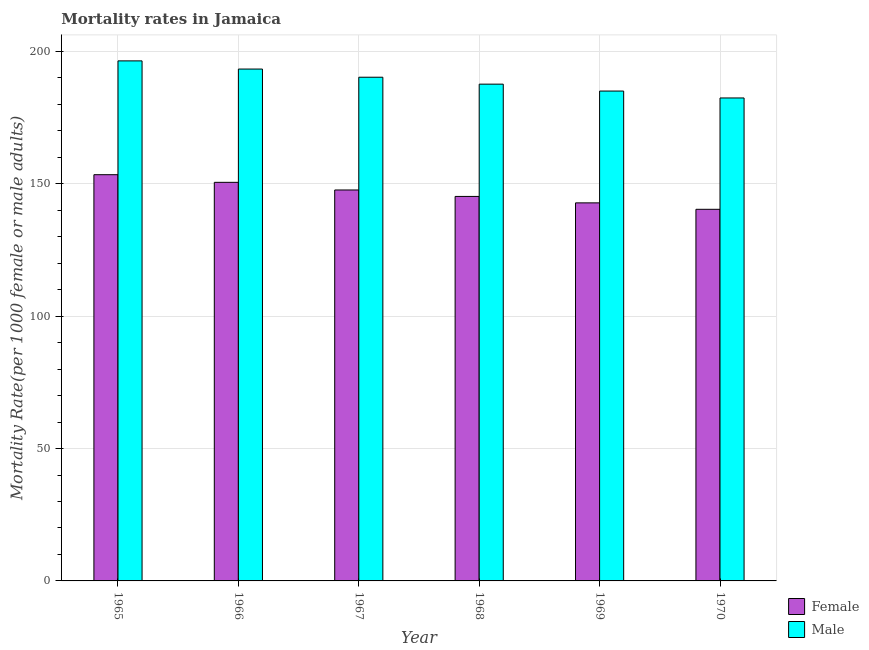How many different coloured bars are there?
Give a very brief answer. 2. Are the number of bars on each tick of the X-axis equal?
Ensure brevity in your answer.  Yes. How many bars are there on the 5th tick from the left?
Provide a succinct answer. 2. How many bars are there on the 2nd tick from the right?
Your response must be concise. 2. What is the label of the 1st group of bars from the left?
Offer a terse response. 1965. In how many cases, is the number of bars for a given year not equal to the number of legend labels?
Keep it short and to the point. 0. What is the male mortality rate in 1968?
Give a very brief answer. 187.66. Across all years, what is the maximum female mortality rate?
Offer a very short reply. 153.45. Across all years, what is the minimum male mortality rate?
Keep it short and to the point. 182.43. In which year was the female mortality rate maximum?
Give a very brief answer. 1965. What is the total female mortality rate in the graph?
Your answer should be compact. 880.11. What is the difference between the female mortality rate in 1966 and that in 1970?
Make the answer very short. 10.19. What is the difference between the female mortality rate in 1969 and the male mortality rate in 1965?
Give a very brief answer. -10.64. What is the average male mortality rate per year?
Offer a very short reply. 189.2. In the year 1970, what is the difference between the female mortality rate and male mortality rate?
Give a very brief answer. 0. In how many years, is the male mortality rate greater than 170?
Make the answer very short. 6. What is the ratio of the female mortality rate in 1966 to that in 1968?
Keep it short and to the point. 1.04. Is the difference between the female mortality rate in 1966 and 1968 greater than the difference between the male mortality rate in 1966 and 1968?
Offer a very short reply. No. What is the difference between the highest and the second highest female mortality rate?
Your answer should be compact. 2.89. What is the difference between the highest and the lowest female mortality rate?
Your answer should be compact. 13.08. Is the sum of the male mortality rate in 1966 and 1970 greater than the maximum female mortality rate across all years?
Offer a very short reply. Yes. What does the 1st bar from the left in 1968 represents?
Your response must be concise. Female. What does the 2nd bar from the right in 1969 represents?
Keep it short and to the point. Female. How many bars are there?
Your answer should be very brief. 12. Are all the bars in the graph horizontal?
Offer a terse response. No. How many years are there in the graph?
Give a very brief answer. 6. Are the values on the major ticks of Y-axis written in scientific E-notation?
Your response must be concise. No. Does the graph contain any zero values?
Your answer should be compact. No. How many legend labels are there?
Make the answer very short. 2. How are the legend labels stacked?
Make the answer very short. Vertical. What is the title of the graph?
Your response must be concise. Mortality rates in Jamaica. What is the label or title of the X-axis?
Your response must be concise. Year. What is the label or title of the Y-axis?
Provide a short and direct response. Mortality Rate(per 1000 female or male adults). What is the Mortality Rate(per 1000 female or male adults) of Female in 1965?
Provide a succinct answer. 153.45. What is the Mortality Rate(per 1000 female or male adults) in Male in 1965?
Provide a succinct answer. 196.44. What is the Mortality Rate(per 1000 female or male adults) in Female in 1966?
Offer a terse response. 150.56. What is the Mortality Rate(per 1000 female or male adults) in Male in 1966?
Ensure brevity in your answer.  193.36. What is the Mortality Rate(per 1000 female or male adults) of Female in 1967?
Make the answer very short. 147.68. What is the Mortality Rate(per 1000 female or male adults) of Male in 1967?
Offer a very short reply. 190.27. What is the Mortality Rate(per 1000 female or male adults) of Female in 1968?
Keep it short and to the point. 145.24. What is the Mortality Rate(per 1000 female or male adults) in Male in 1968?
Ensure brevity in your answer.  187.66. What is the Mortality Rate(per 1000 female or male adults) of Female in 1969?
Offer a terse response. 142.81. What is the Mortality Rate(per 1000 female or male adults) of Male in 1969?
Give a very brief answer. 185.04. What is the Mortality Rate(per 1000 female or male adults) in Female in 1970?
Offer a very short reply. 140.37. What is the Mortality Rate(per 1000 female or male adults) of Male in 1970?
Your response must be concise. 182.43. Across all years, what is the maximum Mortality Rate(per 1000 female or male adults) of Female?
Provide a short and direct response. 153.45. Across all years, what is the maximum Mortality Rate(per 1000 female or male adults) in Male?
Give a very brief answer. 196.44. Across all years, what is the minimum Mortality Rate(per 1000 female or male adults) in Female?
Give a very brief answer. 140.37. Across all years, what is the minimum Mortality Rate(per 1000 female or male adults) of Male?
Offer a terse response. 182.43. What is the total Mortality Rate(per 1000 female or male adults) of Female in the graph?
Give a very brief answer. 880.11. What is the total Mortality Rate(per 1000 female or male adults) of Male in the graph?
Offer a terse response. 1135.2. What is the difference between the Mortality Rate(per 1000 female or male adults) of Female in 1965 and that in 1966?
Your response must be concise. 2.89. What is the difference between the Mortality Rate(per 1000 female or male adults) of Male in 1965 and that in 1966?
Ensure brevity in your answer.  3.09. What is the difference between the Mortality Rate(per 1000 female or male adults) in Female in 1965 and that in 1967?
Ensure brevity in your answer.  5.78. What is the difference between the Mortality Rate(per 1000 female or male adults) in Male in 1965 and that in 1967?
Offer a very short reply. 6.18. What is the difference between the Mortality Rate(per 1000 female or male adults) in Female in 1965 and that in 1968?
Offer a terse response. 8.21. What is the difference between the Mortality Rate(per 1000 female or male adults) in Male in 1965 and that in 1968?
Your response must be concise. 8.79. What is the difference between the Mortality Rate(per 1000 female or male adults) of Female in 1965 and that in 1969?
Provide a short and direct response. 10.64. What is the difference between the Mortality Rate(per 1000 female or male adults) of Male in 1965 and that in 1969?
Make the answer very short. 11.4. What is the difference between the Mortality Rate(per 1000 female or male adults) of Female in 1965 and that in 1970?
Offer a terse response. 13.08. What is the difference between the Mortality Rate(per 1000 female or male adults) in Male in 1965 and that in 1970?
Keep it short and to the point. 14.01. What is the difference between the Mortality Rate(per 1000 female or male adults) of Female in 1966 and that in 1967?
Provide a succinct answer. 2.89. What is the difference between the Mortality Rate(per 1000 female or male adults) of Male in 1966 and that in 1967?
Provide a succinct answer. 3.09. What is the difference between the Mortality Rate(per 1000 female or male adults) of Female in 1966 and that in 1968?
Your response must be concise. 5.32. What is the difference between the Mortality Rate(per 1000 female or male adults) of Male in 1966 and that in 1968?
Provide a short and direct response. 5.7. What is the difference between the Mortality Rate(per 1000 female or male adults) in Female in 1966 and that in 1969?
Offer a terse response. 7.76. What is the difference between the Mortality Rate(per 1000 female or male adults) of Male in 1966 and that in 1969?
Make the answer very short. 8.31. What is the difference between the Mortality Rate(per 1000 female or male adults) in Female in 1966 and that in 1970?
Ensure brevity in your answer.  10.19. What is the difference between the Mortality Rate(per 1000 female or male adults) in Male in 1966 and that in 1970?
Your answer should be very brief. 10.92. What is the difference between the Mortality Rate(per 1000 female or male adults) of Female in 1967 and that in 1968?
Ensure brevity in your answer.  2.43. What is the difference between the Mortality Rate(per 1000 female or male adults) of Male in 1967 and that in 1968?
Provide a succinct answer. 2.61. What is the difference between the Mortality Rate(per 1000 female or male adults) of Female in 1967 and that in 1969?
Your answer should be compact. 4.87. What is the difference between the Mortality Rate(per 1000 female or male adults) in Male in 1967 and that in 1969?
Ensure brevity in your answer.  5.22. What is the difference between the Mortality Rate(per 1000 female or male adults) of Female in 1967 and that in 1970?
Your answer should be compact. 7.3. What is the difference between the Mortality Rate(per 1000 female or male adults) of Male in 1967 and that in 1970?
Provide a succinct answer. 7.83. What is the difference between the Mortality Rate(per 1000 female or male adults) in Female in 1968 and that in 1969?
Offer a terse response. 2.43. What is the difference between the Mortality Rate(per 1000 female or male adults) in Male in 1968 and that in 1969?
Make the answer very short. 2.61. What is the difference between the Mortality Rate(per 1000 female or male adults) in Female in 1968 and that in 1970?
Give a very brief answer. 4.87. What is the difference between the Mortality Rate(per 1000 female or male adults) of Male in 1968 and that in 1970?
Your answer should be compact. 5.22. What is the difference between the Mortality Rate(per 1000 female or male adults) of Female in 1969 and that in 1970?
Provide a succinct answer. 2.43. What is the difference between the Mortality Rate(per 1000 female or male adults) in Male in 1969 and that in 1970?
Your answer should be compact. 2.61. What is the difference between the Mortality Rate(per 1000 female or male adults) of Female in 1965 and the Mortality Rate(per 1000 female or male adults) of Male in 1966?
Your answer should be compact. -39.9. What is the difference between the Mortality Rate(per 1000 female or male adults) in Female in 1965 and the Mortality Rate(per 1000 female or male adults) in Male in 1967?
Provide a succinct answer. -36.82. What is the difference between the Mortality Rate(per 1000 female or male adults) of Female in 1965 and the Mortality Rate(per 1000 female or male adults) of Male in 1968?
Provide a short and direct response. -34.2. What is the difference between the Mortality Rate(per 1000 female or male adults) in Female in 1965 and the Mortality Rate(per 1000 female or male adults) in Male in 1969?
Give a very brief answer. -31.59. What is the difference between the Mortality Rate(per 1000 female or male adults) in Female in 1965 and the Mortality Rate(per 1000 female or male adults) in Male in 1970?
Ensure brevity in your answer.  -28.98. What is the difference between the Mortality Rate(per 1000 female or male adults) of Female in 1966 and the Mortality Rate(per 1000 female or male adults) of Male in 1967?
Keep it short and to the point. -39.7. What is the difference between the Mortality Rate(per 1000 female or male adults) in Female in 1966 and the Mortality Rate(per 1000 female or male adults) in Male in 1968?
Your response must be concise. -37.09. What is the difference between the Mortality Rate(per 1000 female or male adults) of Female in 1966 and the Mortality Rate(per 1000 female or male adults) of Male in 1969?
Offer a terse response. -34.48. What is the difference between the Mortality Rate(per 1000 female or male adults) of Female in 1966 and the Mortality Rate(per 1000 female or male adults) of Male in 1970?
Offer a very short reply. -31.87. What is the difference between the Mortality Rate(per 1000 female or male adults) in Female in 1967 and the Mortality Rate(per 1000 female or male adults) in Male in 1968?
Your answer should be very brief. -39.98. What is the difference between the Mortality Rate(per 1000 female or male adults) in Female in 1967 and the Mortality Rate(per 1000 female or male adults) in Male in 1969?
Offer a very short reply. -37.37. What is the difference between the Mortality Rate(per 1000 female or male adults) in Female in 1967 and the Mortality Rate(per 1000 female or male adults) in Male in 1970?
Offer a terse response. -34.76. What is the difference between the Mortality Rate(per 1000 female or male adults) in Female in 1968 and the Mortality Rate(per 1000 female or male adults) in Male in 1969?
Keep it short and to the point. -39.8. What is the difference between the Mortality Rate(per 1000 female or male adults) in Female in 1968 and the Mortality Rate(per 1000 female or male adults) in Male in 1970?
Your answer should be compact. -37.19. What is the difference between the Mortality Rate(per 1000 female or male adults) in Female in 1969 and the Mortality Rate(per 1000 female or male adults) in Male in 1970?
Give a very brief answer. -39.63. What is the average Mortality Rate(per 1000 female or male adults) in Female per year?
Make the answer very short. 146.69. What is the average Mortality Rate(per 1000 female or male adults) in Male per year?
Ensure brevity in your answer.  189.2. In the year 1965, what is the difference between the Mortality Rate(per 1000 female or male adults) of Female and Mortality Rate(per 1000 female or male adults) of Male?
Provide a succinct answer. -42.99. In the year 1966, what is the difference between the Mortality Rate(per 1000 female or male adults) of Female and Mortality Rate(per 1000 female or male adults) of Male?
Offer a terse response. -42.79. In the year 1967, what is the difference between the Mortality Rate(per 1000 female or male adults) in Female and Mortality Rate(per 1000 female or male adults) in Male?
Your response must be concise. -42.59. In the year 1968, what is the difference between the Mortality Rate(per 1000 female or male adults) of Female and Mortality Rate(per 1000 female or male adults) of Male?
Your response must be concise. -42.41. In the year 1969, what is the difference between the Mortality Rate(per 1000 female or male adults) of Female and Mortality Rate(per 1000 female or male adults) of Male?
Your response must be concise. -42.24. In the year 1970, what is the difference between the Mortality Rate(per 1000 female or male adults) of Female and Mortality Rate(per 1000 female or male adults) of Male?
Your answer should be very brief. -42.06. What is the ratio of the Mortality Rate(per 1000 female or male adults) of Female in 1965 to that in 1966?
Give a very brief answer. 1.02. What is the ratio of the Mortality Rate(per 1000 female or male adults) in Female in 1965 to that in 1967?
Make the answer very short. 1.04. What is the ratio of the Mortality Rate(per 1000 female or male adults) in Male in 1965 to that in 1967?
Offer a very short reply. 1.03. What is the ratio of the Mortality Rate(per 1000 female or male adults) in Female in 1965 to that in 1968?
Keep it short and to the point. 1.06. What is the ratio of the Mortality Rate(per 1000 female or male adults) in Male in 1965 to that in 1968?
Your answer should be very brief. 1.05. What is the ratio of the Mortality Rate(per 1000 female or male adults) of Female in 1965 to that in 1969?
Your answer should be compact. 1.07. What is the ratio of the Mortality Rate(per 1000 female or male adults) in Male in 1965 to that in 1969?
Provide a succinct answer. 1.06. What is the ratio of the Mortality Rate(per 1000 female or male adults) in Female in 1965 to that in 1970?
Make the answer very short. 1.09. What is the ratio of the Mortality Rate(per 1000 female or male adults) of Male in 1965 to that in 1970?
Keep it short and to the point. 1.08. What is the ratio of the Mortality Rate(per 1000 female or male adults) of Female in 1966 to that in 1967?
Your answer should be very brief. 1.02. What is the ratio of the Mortality Rate(per 1000 female or male adults) in Male in 1966 to that in 1967?
Provide a succinct answer. 1.02. What is the ratio of the Mortality Rate(per 1000 female or male adults) of Female in 1966 to that in 1968?
Make the answer very short. 1.04. What is the ratio of the Mortality Rate(per 1000 female or male adults) in Male in 1966 to that in 1968?
Provide a short and direct response. 1.03. What is the ratio of the Mortality Rate(per 1000 female or male adults) in Female in 1966 to that in 1969?
Offer a terse response. 1.05. What is the ratio of the Mortality Rate(per 1000 female or male adults) of Male in 1966 to that in 1969?
Make the answer very short. 1.04. What is the ratio of the Mortality Rate(per 1000 female or male adults) in Female in 1966 to that in 1970?
Your answer should be compact. 1.07. What is the ratio of the Mortality Rate(per 1000 female or male adults) in Male in 1966 to that in 1970?
Make the answer very short. 1.06. What is the ratio of the Mortality Rate(per 1000 female or male adults) of Female in 1967 to that in 1968?
Keep it short and to the point. 1.02. What is the ratio of the Mortality Rate(per 1000 female or male adults) in Male in 1967 to that in 1968?
Ensure brevity in your answer.  1.01. What is the ratio of the Mortality Rate(per 1000 female or male adults) of Female in 1967 to that in 1969?
Give a very brief answer. 1.03. What is the ratio of the Mortality Rate(per 1000 female or male adults) in Male in 1967 to that in 1969?
Make the answer very short. 1.03. What is the ratio of the Mortality Rate(per 1000 female or male adults) of Female in 1967 to that in 1970?
Ensure brevity in your answer.  1.05. What is the ratio of the Mortality Rate(per 1000 female or male adults) in Male in 1967 to that in 1970?
Offer a very short reply. 1.04. What is the ratio of the Mortality Rate(per 1000 female or male adults) in Female in 1968 to that in 1969?
Give a very brief answer. 1.02. What is the ratio of the Mortality Rate(per 1000 female or male adults) in Male in 1968 to that in 1969?
Provide a short and direct response. 1.01. What is the ratio of the Mortality Rate(per 1000 female or male adults) in Female in 1968 to that in 1970?
Keep it short and to the point. 1.03. What is the ratio of the Mortality Rate(per 1000 female or male adults) of Male in 1968 to that in 1970?
Your answer should be very brief. 1.03. What is the ratio of the Mortality Rate(per 1000 female or male adults) in Female in 1969 to that in 1970?
Your answer should be very brief. 1.02. What is the ratio of the Mortality Rate(per 1000 female or male adults) of Male in 1969 to that in 1970?
Offer a very short reply. 1.01. What is the difference between the highest and the second highest Mortality Rate(per 1000 female or male adults) of Female?
Your response must be concise. 2.89. What is the difference between the highest and the second highest Mortality Rate(per 1000 female or male adults) of Male?
Make the answer very short. 3.09. What is the difference between the highest and the lowest Mortality Rate(per 1000 female or male adults) of Female?
Offer a very short reply. 13.08. What is the difference between the highest and the lowest Mortality Rate(per 1000 female or male adults) in Male?
Your answer should be compact. 14.01. 